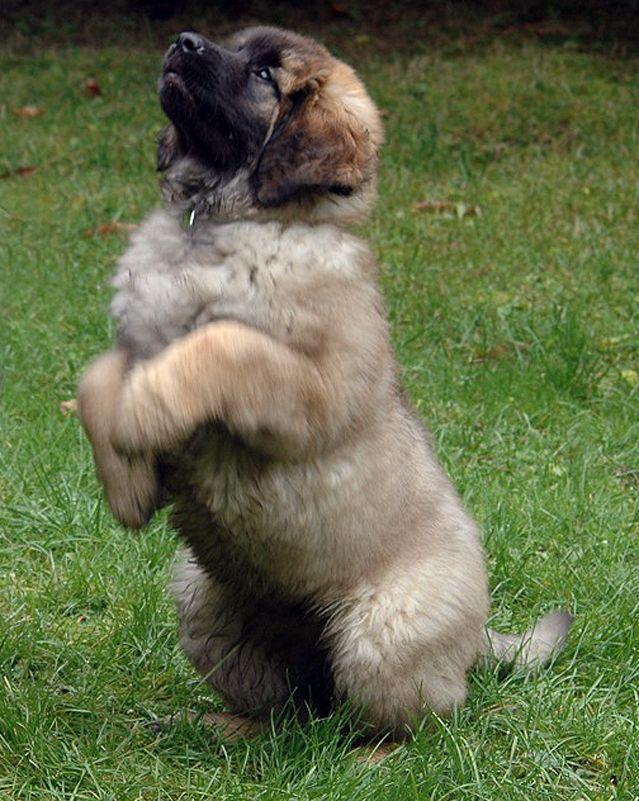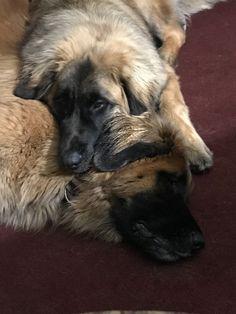The first image is the image on the left, the second image is the image on the right. Given the left and right images, does the statement "All of the dogs are outside and some of them are sleeping." hold true? Answer yes or no. No. The first image is the image on the left, the second image is the image on the right. Analyze the images presented: Is the assertion "The single dog in the left image appears to be lying down." valid? Answer yes or no. No. 